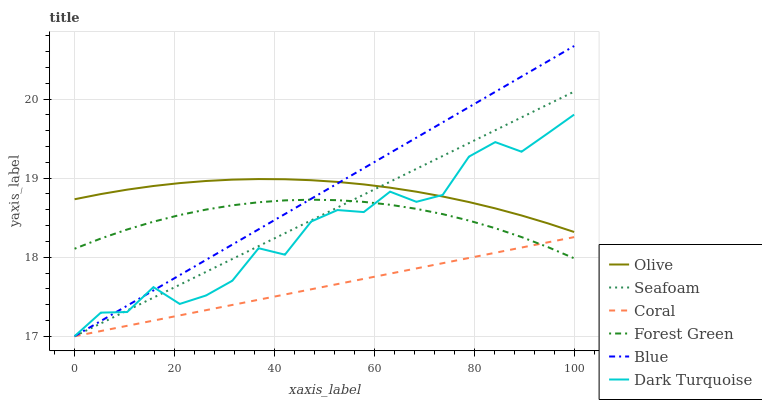Does Coral have the minimum area under the curve?
Answer yes or no. Yes. Does Blue have the maximum area under the curve?
Answer yes or no. Yes. Does Dark Turquoise have the minimum area under the curve?
Answer yes or no. No. Does Dark Turquoise have the maximum area under the curve?
Answer yes or no. No. Is Seafoam the smoothest?
Answer yes or no. Yes. Is Dark Turquoise the roughest?
Answer yes or no. Yes. Is Coral the smoothest?
Answer yes or no. No. Is Coral the roughest?
Answer yes or no. No. Does Forest Green have the lowest value?
Answer yes or no. No. Does Blue have the highest value?
Answer yes or no. Yes. Does Dark Turquoise have the highest value?
Answer yes or no. No. Is Forest Green less than Olive?
Answer yes or no. Yes. Is Olive greater than Forest Green?
Answer yes or no. Yes. Does Seafoam intersect Coral?
Answer yes or no. Yes. Is Seafoam less than Coral?
Answer yes or no. No. Is Seafoam greater than Coral?
Answer yes or no. No. Does Forest Green intersect Olive?
Answer yes or no. No. 